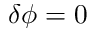Convert formula to latex. <formula><loc_0><loc_0><loc_500><loc_500>\delta \phi = 0</formula> 